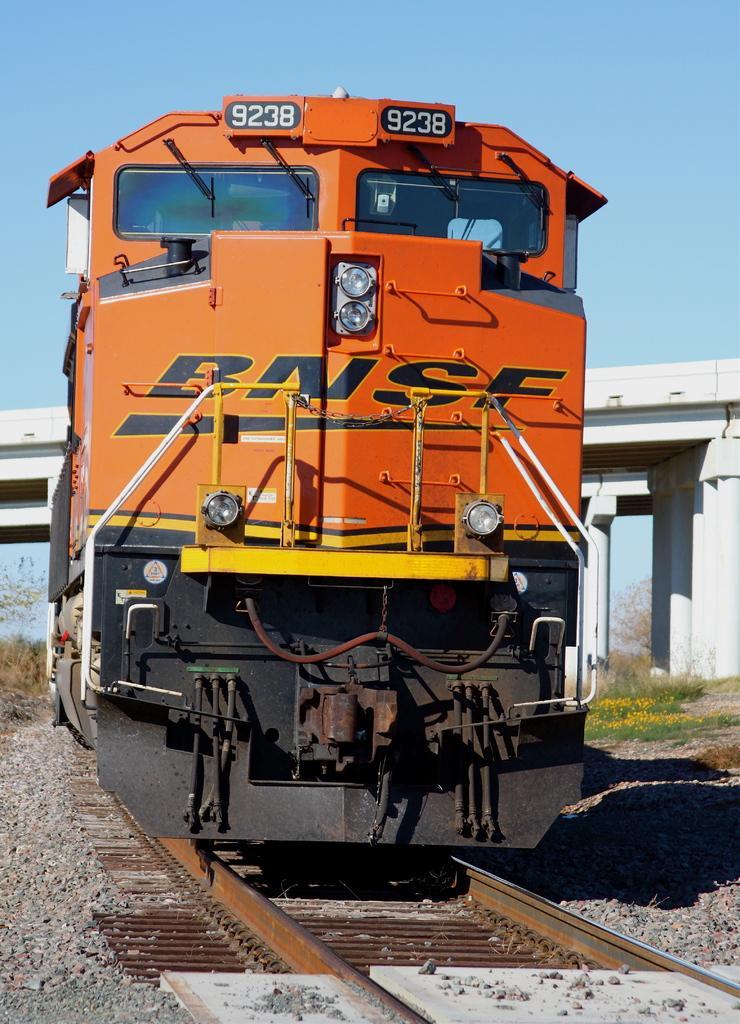Please provide a concise description of this image. In this picture we can see a train on a railway track and in the background we can see a bridge, trees, sky. 